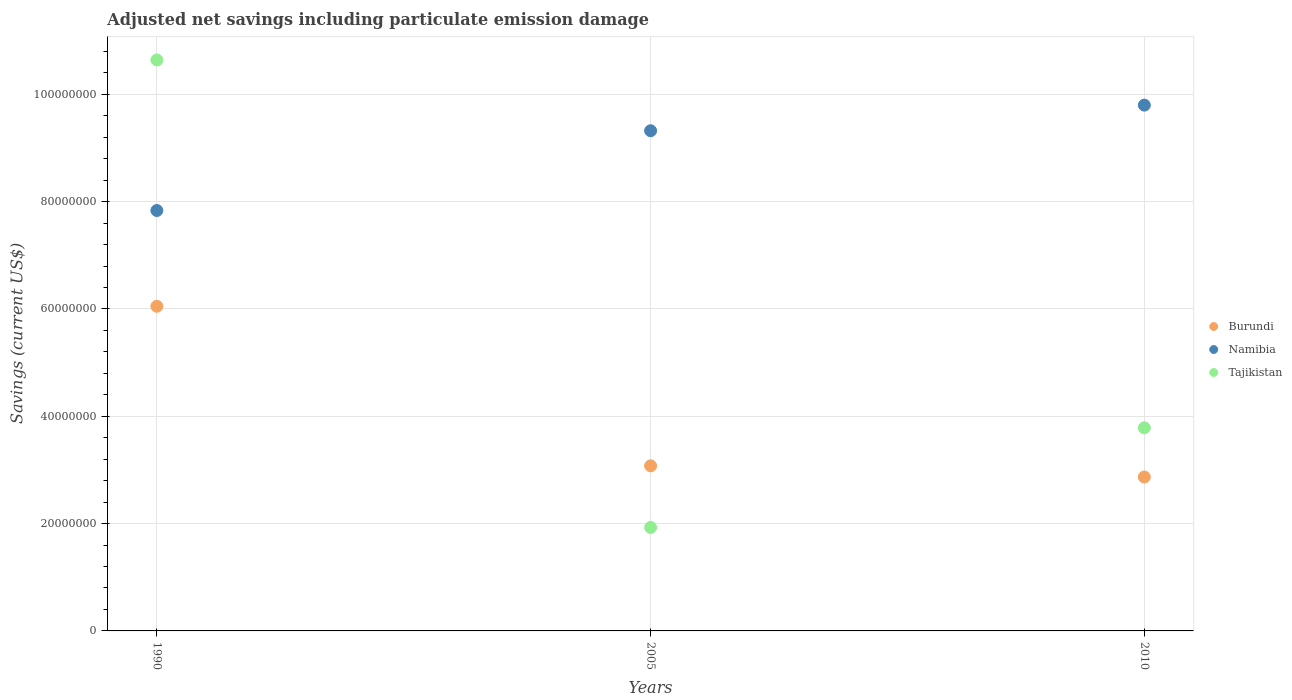How many different coloured dotlines are there?
Your response must be concise. 3. What is the net savings in Tajikistan in 2010?
Your answer should be very brief. 3.79e+07. Across all years, what is the maximum net savings in Tajikistan?
Provide a short and direct response. 1.06e+08. Across all years, what is the minimum net savings in Namibia?
Your answer should be compact. 7.84e+07. In which year was the net savings in Burundi maximum?
Ensure brevity in your answer.  1990. What is the total net savings in Namibia in the graph?
Ensure brevity in your answer.  2.70e+08. What is the difference between the net savings in Namibia in 1990 and that in 2005?
Your answer should be very brief. -1.49e+07. What is the difference between the net savings in Tajikistan in 2005 and the net savings in Namibia in 1990?
Make the answer very short. -5.91e+07. What is the average net savings in Namibia per year?
Offer a very short reply. 8.99e+07. In the year 2010, what is the difference between the net savings in Burundi and net savings in Namibia?
Your answer should be compact. -6.93e+07. In how many years, is the net savings in Tajikistan greater than 104000000 US$?
Give a very brief answer. 1. What is the ratio of the net savings in Namibia in 1990 to that in 2010?
Offer a terse response. 0.8. What is the difference between the highest and the second highest net savings in Namibia?
Keep it short and to the point. 4.78e+06. What is the difference between the highest and the lowest net savings in Burundi?
Provide a short and direct response. 3.18e+07. In how many years, is the net savings in Tajikistan greater than the average net savings in Tajikistan taken over all years?
Your answer should be very brief. 1. Is the sum of the net savings in Burundi in 1990 and 2010 greater than the maximum net savings in Tajikistan across all years?
Keep it short and to the point. No. Is the net savings in Burundi strictly greater than the net savings in Namibia over the years?
Keep it short and to the point. No. Is the net savings in Namibia strictly less than the net savings in Burundi over the years?
Keep it short and to the point. No. How many years are there in the graph?
Your answer should be very brief. 3. What is the difference between two consecutive major ticks on the Y-axis?
Give a very brief answer. 2.00e+07. Are the values on the major ticks of Y-axis written in scientific E-notation?
Your response must be concise. No. Does the graph contain grids?
Your answer should be compact. Yes. How are the legend labels stacked?
Your response must be concise. Vertical. What is the title of the graph?
Make the answer very short. Adjusted net savings including particulate emission damage. Does "Philippines" appear as one of the legend labels in the graph?
Offer a very short reply. No. What is the label or title of the Y-axis?
Provide a short and direct response. Savings (current US$). What is the Savings (current US$) of Burundi in 1990?
Provide a succinct answer. 6.05e+07. What is the Savings (current US$) in Namibia in 1990?
Provide a short and direct response. 7.84e+07. What is the Savings (current US$) in Tajikistan in 1990?
Your answer should be compact. 1.06e+08. What is the Savings (current US$) of Burundi in 2005?
Offer a very short reply. 3.08e+07. What is the Savings (current US$) of Namibia in 2005?
Ensure brevity in your answer.  9.32e+07. What is the Savings (current US$) of Tajikistan in 2005?
Offer a terse response. 1.93e+07. What is the Savings (current US$) of Burundi in 2010?
Make the answer very short. 2.87e+07. What is the Savings (current US$) of Namibia in 2010?
Your answer should be compact. 9.80e+07. What is the Savings (current US$) of Tajikistan in 2010?
Your answer should be very brief. 3.79e+07. Across all years, what is the maximum Savings (current US$) of Burundi?
Offer a terse response. 6.05e+07. Across all years, what is the maximum Savings (current US$) of Namibia?
Keep it short and to the point. 9.80e+07. Across all years, what is the maximum Savings (current US$) in Tajikistan?
Your answer should be compact. 1.06e+08. Across all years, what is the minimum Savings (current US$) in Burundi?
Your answer should be very brief. 2.87e+07. Across all years, what is the minimum Savings (current US$) in Namibia?
Offer a very short reply. 7.84e+07. Across all years, what is the minimum Savings (current US$) of Tajikistan?
Provide a short and direct response. 1.93e+07. What is the total Savings (current US$) of Burundi in the graph?
Keep it short and to the point. 1.20e+08. What is the total Savings (current US$) of Namibia in the graph?
Offer a terse response. 2.70e+08. What is the total Savings (current US$) of Tajikistan in the graph?
Provide a succinct answer. 1.64e+08. What is the difference between the Savings (current US$) of Burundi in 1990 and that in 2005?
Provide a succinct answer. 2.97e+07. What is the difference between the Savings (current US$) in Namibia in 1990 and that in 2005?
Offer a terse response. -1.49e+07. What is the difference between the Savings (current US$) of Tajikistan in 1990 and that in 2005?
Provide a succinct answer. 8.71e+07. What is the difference between the Savings (current US$) in Burundi in 1990 and that in 2010?
Your answer should be compact. 3.18e+07. What is the difference between the Savings (current US$) of Namibia in 1990 and that in 2010?
Provide a short and direct response. -1.96e+07. What is the difference between the Savings (current US$) in Tajikistan in 1990 and that in 2010?
Provide a succinct answer. 6.86e+07. What is the difference between the Savings (current US$) of Burundi in 2005 and that in 2010?
Provide a short and direct response. 2.09e+06. What is the difference between the Savings (current US$) of Namibia in 2005 and that in 2010?
Provide a short and direct response. -4.78e+06. What is the difference between the Savings (current US$) of Tajikistan in 2005 and that in 2010?
Give a very brief answer. -1.86e+07. What is the difference between the Savings (current US$) of Burundi in 1990 and the Savings (current US$) of Namibia in 2005?
Your response must be concise. -3.27e+07. What is the difference between the Savings (current US$) of Burundi in 1990 and the Savings (current US$) of Tajikistan in 2005?
Your answer should be compact. 4.12e+07. What is the difference between the Savings (current US$) of Namibia in 1990 and the Savings (current US$) of Tajikistan in 2005?
Provide a short and direct response. 5.91e+07. What is the difference between the Savings (current US$) of Burundi in 1990 and the Savings (current US$) of Namibia in 2010?
Offer a terse response. -3.75e+07. What is the difference between the Savings (current US$) in Burundi in 1990 and the Savings (current US$) in Tajikistan in 2010?
Offer a very short reply. 2.26e+07. What is the difference between the Savings (current US$) in Namibia in 1990 and the Savings (current US$) in Tajikistan in 2010?
Offer a very short reply. 4.05e+07. What is the difference between the Savings (current US$) of Burundi in 2005 and the Savings (current US$) of Namibia in 2010?
Ensure brevity in your answer.  -6.72e+07. What is the difference between the Savings (current US$) of Burundi in 2005 and the Savings (current US$) of Tajikistan in 2010?
Your response must be concise. -7.09e+06. What is the difference between the Savings (current US$) in Namibia in 2005 and the Savings (current US$) in Tajikistan in 2010?
Offer a very short reply. 5.54e+07. What is the average Savings (current US$) of Burundi per year?
Your response must be concise. 4.00e+07. What is the average Savings (current US$) of Namibia per year?
Ensure brevity in your answer.  8.99e+07. What is the average Savings (current US$) of Tajikistan per year?
Ensure brevity in your answer.  5.45e+07. In the year 1990, what is the difference between the Savings (current US$) in Burundi and Savings (current US$) in Namibia?
Provide a succinct answer. -1.78e+07. In the year 1990, what is the difference between the Savings (current US$) of Burundi and Savings (current US$) of Tajikistan?
Make the answer very short. -4.59e+07. In the year 1990, what is the difference between the Savings (current US$) of Namibia and Savings (current US$) of Tajikistan?
Ensure brevity in your answer.  -2.81e+07. In the year 2005, what is the difference between the Savings (current US$) of Burundi and Savings (current US$) of Namibia?
Offer a terse response. -6.24e+07. In the year 2005, what is the difference between the Savings (current US$) of Burundi and Savings (current US$) of Tajikistan?
Ensure brevity in your answer.  1.15e+07. In the year 2005, what is the difference between the Savings (current US$) of Namibia and Savings (current US$) of Tajikistan?
Your answer should be very brief. 7.39e+07. In the year 2010, what is the difference between the Savings (current US$) in Burundi and Savings (current US$) in Namibia?
Give a very brief answer. -6.93e+07. In the year 2010, what is the difference between the Savings (current US$) in Burundi and Savings (current US$) in Tajikistan?
Provide a short and direct response. -9.17e+06. In the year 2010, what is the difference between the Savings (current US$) in Namibia and Savings (current US$) in Tajikistan?
Give a very brief answer. 6.01e+07. What is the ratio of the Savings (current US$) in Burundi in 1990 to that in 2005?
Your response must be concise. 1.97. What is the ratio of the Savings (current US$) in Namibia in 1990 to that in 2005?
Offer a very short reply. 0.84. What is the ratio of the Savings (current US$) of Tajikistan in 1990 to that in 2005?
Your answer should be compact. 5.52. What is the ratio of the Savings (current US$) of Burundi in 1990 to that in 2010?
Make the answer very short. 2.11. What is the ratio of the Savings (current US$) in Namibia in 1990 to that in 2010?
Your response must be concise. 0.8. What is the ratio of the Savings (current US$) of Tajikistan in 1990 to that in 2010?
Offer a very short reply. 2.81. What is the ratio of the Savings (current US$) in Burundi in 2005 to that in 2010?
Keep it short and to the point. 1.07. What is the ratio of the Savings (current US$) in Namibia in 2005 to that in 2010?
Offer a terse response. 0.95. What is the ratio of the Savings (current US$) in Tajikistan in 2005 to that in 2010?
Offer a terse response. 0.51. What is the difference between the highest and the second highest Savings (current US$) in Burundi?
Give a very brief answer. 2.97e+07. What is the difference between the highest and the second highest Savings (current US$) in Namibia?
Ensure brevity in your answer.  4.78e+06. What is the difference between the highest and the second highest Savings (current US$) in Tajikistan?
Offer a terse response. 6.86e+07. What is the difference between the highest and the lowest Savings (current US$) in Burundi?
Your answer should be very brief. 3.18e+07. What is the difference between the highest and the lowest Savings (current US$) of Namibia?
Your response must be concise. 1.96e+07. What is the difference between the highest and the lowest Savings (current US$) in Tajikistan?
Ensure brevity in your answer.  8.71e+07. 